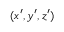<formula> <loc_0><loc_0><loc_500><loc_500>( x ^ { \prime } , y ^ { \prime } , z ^ { \prime } )</formula> 